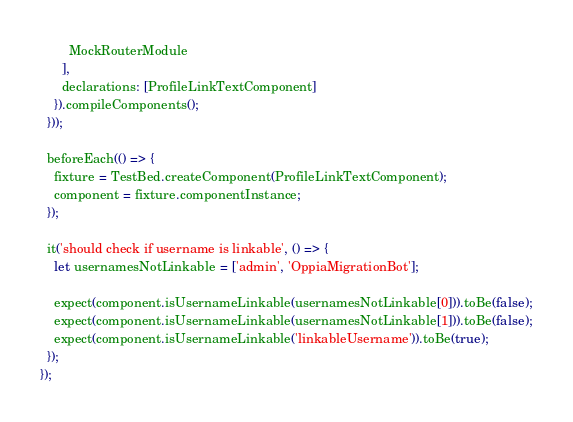Convert code to text. <code><loc_0><loc_0><loc_500><loc_500><_TypeScript_>        MockRouterModule
      ],
      declarations: [ProfileLinkTextComponent]
    }).compileComponents();
  }));

  beforeEach(() => {
    fixture = TestBed.createComponent(ProfileLinkTextComponent);
    component = fixture.componentInstance;
  });

  it('should check if username is linkable', () => {
    let usernamesNotLinkable = ['admin', 'OppiaMigrationBot'];

    expect(component.isUsernameLinkable(usernamesNotLinkable[0])).toBe(false);
    expect(component.isUsernameLinkable(usernamesNotLinkable[1])).toBe(false);
    expect(component.isUsernameLinkable('linkableUsername')).toBe(true);
  });
});
</code> 